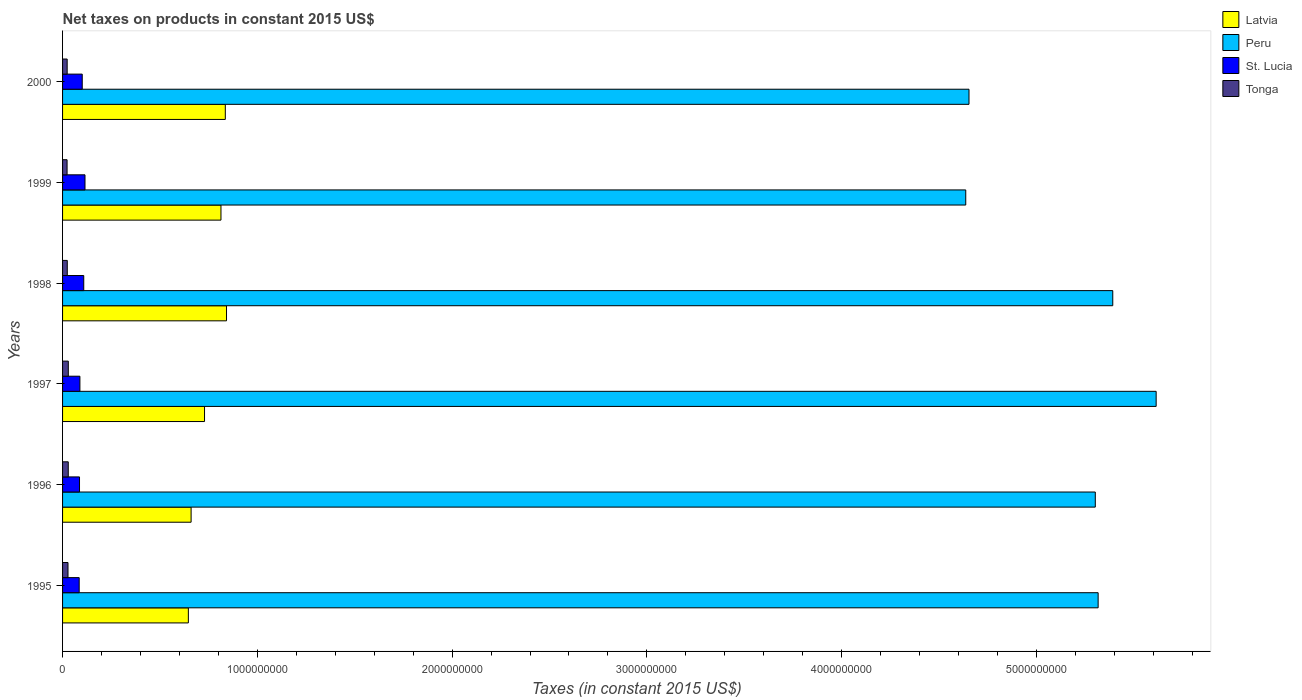Are the number of bars per tick equal to the number of legend labels?
Keep it short and to the point. Yes. Are the number of bars on each tick of the Y-axis equal?
Offer a terse response. Yes. How many bars are there on the 2nd tick from the bottom?
Offer a very short reply. 4. What is the label of the 3rd group of bars from the top?
Keep it short and to the point. 1998. What is the net taxes on products in Tonga in 1999?
Your answer should be very brief. 2.32e+07. Across all years, what is the maximum net taxes on products in Latvia?
Provide a short and direct response. 8.42e+08. Across all years, what is the minimum net taxes on products in Latvia?
Your answer should be compact. 6.46e+08. In which year was the net taxes on products in Latvia maximum?
Ensure brevity in your answer.  1998. In which year was the net taxes on products in Tonga minimum?
Offer a terse response. 1999. What is the total net taxes on products in Latvia in the graph?
Your answer should be compact. 4.53e+09. What is the difference between the net taxes on products in Tonga in 1995 and that in 1998?
Give a very brief answer. 3.73e+06. What is the difference between the net taxes on products in Tonga in 1996 and the net taxes on products in Latvia in 1999?
Keep it short and to the point. -7.84e+08. What is the average net taxes on products in Latvia per year?
Provide a short and direct response. 7.54e+08. In the year 1997, what is the difference between the net taxes on products in Latvia and net taxes on products in Tonga?
Offer a very short reply. 6.99e+08. In how many years, is the net taxes on products in St. Lucia greater than 5400000000 US$?
Your answer should be very brief. 0. What is the ratio of the net taxes on products in Peru in 1997 to that in 1998?
Provide a succinct answer. 1.04. What is the difference between the highest and the second highest net taxes on products in St. Lucia?
Your response must be concise. 6.39e+06. What is the difference between the highest and the lowest net taxes on products in St. Lucia?
Provide a short and direct response. 2.98e+07. Is the sum of the net taxes on products in Latvia in 1996 and 1999 greater than the maximum net taxes on products in St. Lucia across all years?
Provide a short and direct response. Yes. What does the 1st bar from the top in 1998 represents?
Make the answer very short. Tonga. What does the 3rd bar from the bottom in 1998 represents?
Your response must be concise. St. Lucia. What is the difference between two consecutive major ticks on the X-axis?
Give a very brief answer. 1.00e+09. Does the graph contain grids?
Keep it short and to the point. No. How many legend labels are there?
Give a very brief answer. 4. What is the title of the graph?
Ensure brevity in your answer.  Net taxes on products in constant 2015 US$. Does "Greece" appear as one of the legend labels in the graph?
Ensure brevity in your answer.  No. What is the label or title of the X-axis?
Give a very brief answer. Taxes (in constant 2015 US$). What is the Taxes (in constant 2015 US$) in Latvia in 1995?
Ensure brevity in your answer.  6.46e+08. What is the Taxes (in constant 2015 US$) in Peru in 1995?
Ensure brevity in your answer.  5.32e+09. What is the Taxes (in constant 2015 US$) of St. Lucia in 1995?
Your response must be concise. 8.54e+07. What is the Taxes (in constant 2015 US$) in Tonga in 1995?
Provide a succinct answer. 2.79e+07. What is the Taxes (in constant 2015 US$) in Latvia in 1996?
Your answer should be compact. 6.60e+08. What is the Taxes (in constant 2015 US$) in Peru in 1996?
Your answer should be compact. 5.30e+09. What is the Taxes (in constant 2015 US$) in St. Lucia in 1996?
Your answer should be compact. 8.70e+07. What is the Taxes (in constant 2015 US$) of Tonga in 1996?
Provide a short and direct response. 2.92e+07. What is the Taxes (in constant 2015 US$) of Latvia in 1997?
Keep it short and to the point. 7.29e+08. What is the Taxes (in constant 2015 US$) of Peru in 1997?
Your response must be concise. 5.61e+09. What is the Taxes (in constant 2015 US$) of St. Lucia in 1997?
Keep it short and to the point. 8.90e+07. What is the Taxes (in constant 2015 US$) of Tonga in 1997?
Your answer should be very brief. 2.95e+07. What is the Taxes (in constant 2015 US$) of Latvia in 1998?
Provide a succinct answer. 8.42e+08. What is the Taxes (in constant 2015 US$) in Peru in 1998?
Offer a very short reply. 5.39e+09. What is the Taxes (in constant 2015 US$) in St. Lucia in 1998?
Offer a terse response. 1.09e+08. What is the Taxes (in constant 2015 US$) of Tonga in 1998?
Keep it short and to the point. 2.42e+07. What is the Taxes (in constant 2015 US$) of Latvia in 1999?
Offer a terse response. 8.13e+08. What is the Taxes (in constant 2015 US$) in Peru in 1999?
Offer a very short reply. 4.64e+09. What is the Taxes (in constant 2015 US$) in St. Lucia in 1999?
Keep it short and to the point. 1.15e+08. What is the Taxes (in constant 2015 US$) of Tonga in 1999?
Keep it short and to the point. 2.32e+07. What is the Taxes (in constant 2015 US$) in Latvia in 2000?
Keep it short and to the point. 8.36e+08. What is the Taxes (in constant 2015 US$) of Peru in 2000?
Make the answer very short. 4.65e+09. What is the Taxes (in constant 2015 US$) of St. Lucia in 2000?
Your answer should be compact. 1.01e+08. What is the Taxes (in constant 2015 US$) in Tonga in 2000?
Provide a short and direct response. 2.36e+07. Across all years, what is the maximum Taxes (in constant 2015 US$) in Latvia?
Your answer should be compact. 8.42e+08. Across all years, what is the maximum Taxes (in constant 2015 US$) of Peru?
Your answer should be compact. 5.61e+09. Across all years, what is the maximum Taxes (in constant 2015 US$) of St. Lucia?
Your answer should be very brief. 1.15e+08. Across all years, what is the maximum Taxes (in constant 2015 US$) in Tonga?
Ensure brevity in your answer.  2.95e+07. Across all years, what is the minimum Taxes (in constant 2015 US$) of Latvia?
Your answer should be very brief. 6.46e+08. Across all years, what is the minimum Taxes (in constant 2015 US$) of Peru?
Keep it short and to the point. 4.64e+09. Across all years, what is the minimum Taxes (in constant 2015 US$) of St. Lucia?
Offer a very short reply. 8.54e+07. Across all years, what is the minimum Taxes (in constant 2015 US$) of Tonga?
Offer a very short reply. 2.32e+07. What is the total Taxes (in constant 2015 US$) of Latvia in the graph?
Your answer should be compact. 4.53e+09. What is the total Taxes (in constant 2015 US$) in Peru in the graph?
Your answer should be compact. 3.09e+1. What is the total Taxes (in constant 2015 US$) in St. Lucia in the graph?
Give a very brief answer. 5.86e+08. What is the total Taxes (in constant 2015 US$) of Tonga in the graph?
Make the answer very short. 1.58e+08. What is the difference between the Taxes (in constant 2015 US$) of Latvia in 1995 and that in 1996?
Offer a terse response. -1.41e+07. What is the difference between the Taxes (in constant 2015 US$) of Peru in 1995 and that in 1996?
Keep it short and to the point. 1.46e+07. What is the difference between the Taxes (in constant 2015 US$) of St. Lucia in 1995 and that in 1996?
Your answer should be compact. -1.67e+06. What is the difference between the Taxes (in constant 2015 US$) in Tonga in 1995 and that in 1996?
Make the answer very short. -1.31e+06. What is the difference between the Taxes (in constant 2015 US$) of Latvia in 1995 and that in 1997?
Your response must be concise. -8.30e+07. What is the difference between the Taxes (in constant 2015 US$) in Peru in 1995 and that in 1997?
Keep it short and to the point. -2.98e+08. What is the difference between the Taxes (in constant 2015 US$) in St. Lucia in 1995 and that in 1997?
Provide a short and direct response. -3.63e+06. What is the difference between the Taxes (in constant 2015 US$) of Tonga in 1995 and that in 1997?
Offer a terse response. -1.54e+06. What is the difference between the Taxes (in constant 2015 US$) of Latvia in 1995 and that in 1998?
Make the answer very short. -1.96e+08. What is the difference between the Taxes (in constant 2015 US$) in Peru in 1995 and that in 1998?
Keep it short and to the point. -7.51e+07. What is the difference between the Taxes (in constant 2015 US$) of St. Lucia in 1995 and that in 1998?
Keep it short and to the point. -2.34e+07. What is the difference between the Taxes (in constant 2015 US$) in Tonga in 1995 and that in 1998?
Provide a succinct answer. 3.73e+06. What is the difference between the Taxes (in constant 2015 US$) in Latvia in 1995 and that in 1999?
Keep it short and to the point. -1.67e+08. What is the difference between the Taxes (in constant 2015 US$) in Peru in 1995 and that in 1999?
Provide a succinct answer. 6.80e+08. What is the difference between the Taxes (in constant 2015 US$) of St. Lucia in 1995 and that in 1999?
Ensure brevity in your answer.  -2.98e+07. What is the difference between the Taxes (in constant 2015 US$) in Tonga in 1995 and that in 1999?
Ensure brevity in your answer.  4.76e+06. What is the difference between the Taxes (in constant 2015 US$) in Latvia in 1995 and that in 2000?
Provide a succinct answer. -1.90e+08. What is the difference between the Taxes (in constant 2015 US$) of Peru in 1995 and that in 2000?
Offer a very short reply. 6.63e+08. What is the difference between the Taxes (in constant 2015 US$) in St. Lucia in 1995 and that in 2000?
Provide a succinct answer. -1.56e+07. What is the difference between the Taxes (in constant 2015 US$) of Tonga in 1995 and that in 2000?
Give a very brief answer. 4.28e+06. What is the difference between the Taxes (in constant 2015 US$) in Latvia in 1996 and that in 1997?
Your response must be concise. -6.89e+07. What is the difference between the Taxes (in constant 2015 US$) in Peru in 1996 and that in 1997?
Ensure brevity in your answer.  -3.12e+08. What is the difference between the Taxes (in constant 2015 US$) in St. Lucia in 1996 and that in 1997?
Keep it short and to the point. -1.96e+06. What is the difference between the Taxes (in constant 2015 US$) in Tonga in 1996 and that in 1997?
Give a very brief answer. -2.30e+05. What is the difference between the Taxes (in constant 2015 US$) in Latvia in 1996 and that in 1998?
Provide a short and direct response. -1.82e+08. What is the difference between the Taxes (in constant 2015 US$) of Peru in 1996 and that in 1998?
Offer a very short reply. -8.97e+07. What is the difference between the Taxes (in constant 2015 US$) of St. Lucia in 1996 and that in 1998?
Offer a terse response. -2.17e+07. What is the difference between the Taxes (in constant 2015 US$) of Tonga in 1996 and that in 1998?
Make the answer very short. 5.04e+06. What is the difference between the Taxes (in constant 2015 US$) in Latvia in 1996 and that in 1999?
Offer a terse response. -1.53e+08. What is the difference between the Taxes (in constant 2015 US$) of Peru in 1996 and that in 1999?
Keep it short and to the point. 6.65e+08. What is the difference between the Taxes (in constant 2015 US$) in St. Lucia in 1996 and that in 1999?
Make the answer very short. -2.81e+07. What is the difference between the Taxes (in constant 2015 US$) of Tonga in 1996 and that in 1999?
Provide a short and direct response. 6.07e+06. What is the difference between the Taxes (in constant 2015 US$) in Latvia in 1996 and that in 2000?
Your response must be concise. -1.76e+08. What is the difference between the Taxes (in constant 2015 US$) of Peru in 1996 and that in 2000?
Make the answer very short. 6.48e+08. What is the difference between the Taxes (in constant 2015 US$) of St. Lucia in 1996 and that in 2000?
Keep it short and to the point. -1.40e+07. What is the difference between the Taxes (in constant 2015 US$) in Tonga in 1996 and that in 2000?
Offer a terse response. 5.59e+06. What is the difference between the Taxes (in constant 2015 US$) in Latvia in 1997 and that in 1998?
Your answer should be compact. -1.13e+08. What is the difference between the Taxes (in constant 2015 US$) in Peru in 1997 and that in 1998?
Ensure brevity in your answer.  2.23e+08. What is the difference between the Taxes (in constant 2015 US$) in St. Lucia in 1997 and that in 1998?
Your answer should be very brief. -1.98e+07. What is the difference between the Taxes (in constant 2015 US$) in Tonga in 1997 and that in 1998?
Provide a short and direct response. 5.27e+06. What is the difference between the Taxes (in constant 2015 US$) of Latvia in 1997 and that in 1999?
Offer a very short reply. -8.44e+07. What is the difference between the Taxes (in constant 2015 US$) of Peru in 1997 and that in 1999?
Give a very brief answer. 9.78e+08. What is the difference between the Taxes (in constant 2015 US$) in St. Lucia in 1997 and that in 1999?
Ensure brevity in your answer.  -2.61e+07. What is the difference between the Taxes (in constant 2015 US$) in Tonga in 1997 and that in 1999?
Provide a succinct answer. 6.30e+06. What is the difference between the Taxes (in constant 2015 US$) in Latvia in 1997 and that in 2000?
Offer a terse response. -1.07e+08. What is the difference between the Taxes (in constant 2015 US$) in Peru in 1997 and that in 2000?
Your response must be concise. 9.61e+08. What is the difference between the Taxes (in constant 2015 US$) in St. Lucia in 1997 and that in 2000?
Your response must be concise. -1.20e+07. What is the difference between the Taxes (in constant 2015 US$) of Tonga in 1997 and that in 2000?
Give a very brief answer. 5.82e+06. What is the difference between the Taxes (in constant 2015 US$) in Latvia in 1998 and that in 1999?
Your answer should be compact. 2.85e+07. What is the difference between the Taxes (in constant 2015 US$) in Peru in 1998 and that in 1999?
Give a very brief answer. 7.55e+08. What is the difference between the Taxes (in constant 2015 US$) of St. Lucia in 1998 and that in 1999?
Your answer should be very brief. -6.39e+06. What is the difference between the Taxes (in constant 2015 US$) of Tonga in 1998 and that in 1999?
Provide a succinct answer. 1.03e+06. What is the difference between the Taxes (in constant 2015 US$) in Latvia in 1998 and that in 2000?
Make the answer very short. 6.22e+06. What is the difference between the Taxes (in constant 2015 US$) in Peru in 1998 and that in 2000?
Your response must be concise. 7.38e+08. What is the difference between the Taxes (in constant 2015 US$) in St. Lucia in 1998 and that in 2000?
Your response must be concise. 7.74e+06. What is the difference between the Taxes (in constant 2015 US$) of Tonga in 1998 and that in 2000?
Your answer should be compact. 5.47e+05. What is the difference between the Taxes (in constant 2015 US$) of Latvia in 1999 and that in 2000?
Provide a succinct answer. -2.22e+07. What is the difference between the Taxes (in constant 2015 US$) in Peru in 1999 and that in 2000?
Offer a very short reply. -1.66e+07. What is the difference between the Taxes (in constant 2015 US$) in St. Lucia in 1999 and that in 2000?
Keep it short and to the point. 1.41e+07. What is the difference between the Taxes (in constant 2015 US$) of Tonga in 1999 and that in 2000?
Offer a very short reply. -4.79e+05. What is the difference between the Taxes (in constant 2015 US$) of Latvia in 1995 and the Taxes (in constant 2015 US$) of Peru in 1996?
Give a very brief answer. -4.66e+09. What is the difference between the Taxes (in constant 2015 US$) of Latvia in 1995 and the Taxes (in constant 2015 US$) of St. Lucia in 1996?
Keep it short and to the point. 5.59e+08. What is the difference between the Taxes (in constant 2015 US$) of Latvia in 1995 and the Taxes (in constant 2015 US$) of Tonga in 1996?
Provide a succinct answer. 6.17e+08. What is the difference between the Taxes (in constant 2015 US$) in Peru in 1995 and the Taxes (in constant 2015 US$) in St. Lucia in 1996?
Offer a very short reply. 5.23e+09. What is the difference between the Taxes (in constant 2015 US$) of Peru in 1995 and the Taxes (in constant 2015 US$) of Tonga in 1996?
Provide a short and direct response. 5.29e+09. What is the difference between the Taxes (in constant 2015 US$) in St. Lucia in 1995 and the Taxes (in constant 2015 US$) in Tonga in 1996?
Your response must be concise. 5.61e+07. What is the difference between the Taxes (in constant 2015 US$) of Latvia in 1995 and the Taxes (in constant 2015 US$) of Peru in 1997?
Your response must be concise. -4.97e+09. What is the difference between the Taxes (in constant 2015 US$) in Latvia in 1995 and the Taxes (in constant 2015 US$) in St. Lucia in 1997?
Offer a very short reply. 5.57e+08. What is the difference between the Taxes (in constant 2015 US$) of Latvia in 1995 and the Taxes (in constant 2015 US$) of Tonga in 1997?
Make the answer very short. 6.16e+08. What is the difference between the Taxes (in constant 2015 US$) of Peru in 1995 and the Taxes (in constant 2015 US$) of St. Lucia in 1997?
Provide a short and direct response. 5.23e+09. What is the difference between the Taxes (in constant 2015 US$) in Peru in 1995 and the Taxes (in constant 2015 US$) in Tonga in 1997?
Make the answer very short. 5.29e+09. What is the difference between the Taxes (in constant 2015 US$) in St. Lucia in 1995 and the Taxes (in constant 2015 US$) in Tonga in 1997?
Your answer should be very brief. 5.59e+07. What is the difference between the Taxes (in constant 2015 US$) in Latvia in 1995 and the Taxes (in constant 2015 US$) in Peru in 1998?
Make the answer very short. -4.75e+09. What is the difference between the Taxes (in constant 2015 US$) of Latvia in 1995 and the Taxes (in constant 2015 US$) of St. Lucia in 1998?
Your answer should be compact. 5.37e+08. What is the difference between the Taxes (in constant 2015 US$) in Latvia in 1995 and the Taxes (in constant 2015 US$) in Tonga in 1998?
Offer a very short reply. 6.22e+08. What is the difference between the Taxes (in constant 2015 US$) of Peru in 1995 and the Taxes (in constant 2015 US$) of St. Lucia in 1998?
Your answer should be compact. 5.21e+09. What is the difference between the Taxes (in constant 2015 US$) in Peru in 1995 and the Taxes (in constant 2015 US$) in Tonga in 1998?
Your response must be concise. 5.29e+09. What is the difference between the Taxes (in constant 2015 US$) in St. Lucia in 1995 and the Taxes (in constant 2015 US$) in Tonga in 1998?
Your answer should be compact. 6.12e+07. What is the difference between the Taxes (in constant 2015 US$) in Latvia in 1995 and the Taxes (in constant 2015 US$) in Peru in 1999?
Make the answer very short. -3.99e+09. What is the difference between the Taxes (in constant 2015 US$) in Latvia in 1995 and the Taxes (in constant 2015 US$) in St. Lucia in 1999?
Keep it short and to the point. 5.31e+08. What is the difference between the Taxes (in constant 2015 US$) of Latvia in 1995 and the Taxes (in constant 2015 US$) of Tonga in 1999?
Provide a short and direct response. 6.23e+08. What is the difference between the Taxes (in constant 2015 US$) of Peru in 1995 and the Taxes (in constant 2015 US$) of St. Lucia in 1999?
Ensure brevity in your answer.  5.20e+09. What is the difference between the Taxes (in constant 2015 US$) of Peru in 1995 and the Taxes (in constant 2015 US$) of Tonga in 1999?
Make the answer very short. 5.29e+09. What is the difference between the Taxes (in constant 2015 US$) in St. Lucia in 1995 and the Taxes (in constant 2015 US$) in Tonga in 1999?
Your answer should be compact. 6.22e+07. What is the difference between the Taxes (in constant 2015 US$) in Latvia in 1995 and the Taxes (in constant 2015 US$) in Peru in 2000?
Provide a succinct answer. -4.01e+09. What is the difference between the Taxes (in constant 2015 US$) of Latvia in 1995 and the Taxes (in constant 2015 US$) of St. Lucia in 2000?
Provide a succinct answer. 5.45e+08. What is the difference between the Taxes (in constant 2015 US$) of Latvia in 1995 and the Taxes (in constant 2015 US$) of Tonga in 2000?
Give a very brief answer. 6.22e+08. What is the difference between the Taxes (in constant 2015 US$) of Peru in 1995 and the Taxes (in constant 2015 US$) of St. Lucia in 2000?
Your response must be concise. 5.22e+09. What is the difference between the Taxes (in constant 2015 US$) of Peru in 1995 and the Taxes (in constant 2015 US$) of Tonga in 2000?
Your answer should be compact. 5.29e+09. What is the difference between the Taxes (in constant 2015 US$) in St. Lucia in 1995 and the Taxes (in constant 2015 US$) in Tonga in 2000?
Make the answer very short. 6.17e+07. What is the difference between the Taxes (in constant 2015 US$) of Latvia in 1996 and the Taxes (in constant 2015 US$) of Peru in 1997?
Provide a short and direct response. -4.95e+09. What is the difference between the Taxes (in constant 2015 US$) in Latvia in 1996 and the Taxes (in constant 2015 US$) in St. Lucia in 1997?
Provide a short and direct response. 5.71e+08. What is the difference between the Taxes (in constant 2015 US$) of Latvia in 1996 and the Taxes (in constant 2015 US$) of Tonga in 1997?
Offer a very short reply. 6.31e+08. What is the difference between the Taxes (in constant 2015 US$) in Peru in 1996 and the Taxes (in constant 2015 US$) in St. Lucia in 1997?
Offer a terse response. 5.21e+09. What is the difference between the Taxes (in constant 2015 US$) of Peru in 1996 and the Taxes (in constant 2015 US$) of Tonga in 1997?
Provide a short and direct response. 5.27e+09. What is the difference between the Taxes (in constant 2015 US$) in St. Lucia in 1996 and the Taxes (in constant 2015 US$) in Tonga in 1997?
Your answer should be very brief. 5.76e+07. What is the difference between the Taxes (in constant 2015 US$) of Latvia in 1996 and the Taxes (in constant 2015 US$) of Peru in 1998?
Provide a succinct answer. -4.73e+09. What is the difference between the Taxes (in constant 2015 US$) of Latvia in 1996 and the Taxes (in constant 2015 US$) of St. Lucia in 1998?
Provide a short and direct response. 5.51e+08. What is the difference between the Taxes (in constant 2015 US$) of Latvia in 1996 and the Taxes (in constant 2015 US$) of Tonga in 1998?
Provide a succinct answer. 6.36e+08. What is the difference between the Taxes (in constant 2015 US$) of Peru in 1996 and the Taxes (in constant 2015 US$) of St. Lucia in 1998?
Your response must be concise. 5.19e+09. What is the difference between the Taxes (in constant 2015 US$) of Peru in 1996 and the Taxes (in constant 2015 US$) of Tonga in 1998?
Your response must be concise. 5.28e+09. What is the difference between the Taxes (in constant 2015 US$) of St. Lucia in 1996 and the Taxes (in constant 2015 US$) of Tonga in 1998?
Make the answer very short. 6.28e+07. What is the difference between the Taxes (in constant 2015 US$) in Latvia in 1996 and the Taxes (in constant 2015 US$) in Peru in 1999?
Make the answer very short. -3.98e+09. What is the difference between the Taxes (in constant 2015 US$) in Latvia in 1996 and the Taxes (in constant 2015 US$) in St. Lucia in 1999?
Make the answer very short. 5.45e+08. What is the difference between the Taxes (in constant 2015 US$) of Latvia in 1996 and the Taxes (in constant 2015 US$) of Tonga in 1999?
Ensure brevity in your answer.  6.37e+08. What is the difference between the Taxes (in constant 2015 US$) in Peru in 1996 and the Taxes (in constant 2015 US$) in St. Lucia in 1999?
Your answer should be very brief. 5.19e+09. What is the difference between the Taxes (in constant 2015 US$) of Peru in 1996 and the Taxes (in constant 2015 US$) of Tonga in 1999?
Provide a succinct answer. 5.28e+09. What is the difference between the Taxes (in constant 2015 US$) of St. Lucia in 1996 and the Taxes (in constant 2015 US$) of Tonga in 1999?
Your response must be concise. 6.39e+07. What is the difference between the Taxes (in constant 2015 US$) in Latvia in 1996 and the Taxes (in constant 2015 US$) in Peru in 2000?
Offer a very short reply. -3.99e+09. What is the difference between the Taxes (in constant 2015 US$) of Latvia in 1996 and the Taxes (in constant 2015 US$) of St. Lucia in 2000?
Make the answer very short. 5.59e+08. What is the difference between the Taxes (in constant 2015 US$) of Latvia in 1996 and the Taxes (in constant 2015 US$) of Tonga in 2000?
Make the answer very short. 6.36e+08. What is the difference between the Taxes (in constant 2015 US$) in Peru in 1996 and the Taxes (in constant 2015 US$) in St. Lucia in 2000?
Your answer should be compact. 5.20e+09. What is the difference between the Taxes (in constant 2015 US$) of Peru in 1996 and the Taxes (in constant 2015 US$) of Tonga in 2000?
Your answer should be compact. 5.28e+09. What is the difference between the Taxes (in constant 2015 US$) in St. Lucia in 1996 and the Taxes (in constant 2015 US$) in Tonga in 2000?
Ensure brevity in your answer.  6.34e+07. What is the difference between the Taxes (in constant 2015 US$) in Latvia in 1997 and the Taxes (in constant 2015 US$) in Peru in 1998?
Provide a short and direct response. -4.66e+09. What is the difference between the Taxes (in constant 2015 US$) in Latvia in 1997 and the Taxes (in constant 2015 US$) in St. Lucia in 1998?
Offer a terse response. 6.20e+08. What is the difference between the Taxes (in constant 2015 US$) in Latvia in 1997 and the Taxes (in constant 2015 US$) in Tonga in 1998?
Offer a terse response. 7.05e+08. What is the difference between the Taxes (in constant 2015 US$) in Peru in 1997 and the Taxes (in constant 2015 US$) in St. Lucia in 1998?
Keep it short and to the point. 5.51e+09. What is the difference between the Taxes (in constant 2015 US$) of Peru in 1997 and the Taxes (in constant 2015 US$) of Tonga in 1998?
Ensure brevity in your answer.  5.59e+09. What is the difference between the Taxes (in constant 2015 US$) of St. Lucia in 1997 and the Taxes (in constant 2015 US$) of Tonga in 1998?
Provide a short and direct response. 6.48e+07. What is the difference between the Taxes (in constant 2015 US$) in Latvia in 1997 and the Taxes (in constant 2015 US$) in Peru in 1999?
Make the answer very short. -3.91e+09. What is the difference between the Taxes (in constant 2015 US$) of Latvia in 1997 and the Taxes (in constant 2015 US$) of St. Lucia in 1999?
Keep it short and to the point. 6.14e+08. What is the difference between the Taxes (in constant 2015 US$) of Latvia in 1997 and the Taxes (in constant 2015 US$) of Tonga in 1999?
Keep it short and to the point. 7.06e+08. What is the difference between the Taxes (in constant 2015 US$) of Peru in 1997 and the Taxes (in constant 2015 US$) of St. Lucia in 1999?
Make the answer very short. 5.50e+09. What is the difference between the Taxes (in constant 2015 US$) of Peru in 1997 and the Taxes (in constant 2015 US$) of Tonga in 1999?
Give a very brief answer. 5.59e+09. What is the difference between the Taxes (in constant 2015 US$) in St. Lucia in 1997 and the Taxes (in constant 2015 US$) in Tonga in 1999?
Keep it short and to the point. 6.58e+07. What is the difference between the Taxes (in constant 2015 US$) in Latvia in 1997 and the Taxes (in constant 2015 US$) in Peru in 2000?
Your answer should be very brief. -3.92e+09. What is the difference between the Taxes (in constant 2015 US$) in Latvia in 1997 and the Taxes (in constant 2015 US$) in St. Lucia in 2000?
Your answer should be compact. 6.28e+08. What is the difference between the Taxes (in constant 2015 US$) in Latvia in 1997 and the Taxes (in constant 2015 US$) in Tonga in 2000?
Keep it short and to the point. 7.05e+08. What is the difference between the Taxes (in constant 2015 US$) of Peru in 1997 and the Taxes (in constant 2015 US$) of St. Lucia in 2000?
Offer a very short reply. 5.51e+09. What is the difference between the Taxes (in constant 2015 US$) of Peru in 1997 and the Taxes (in constant 2015 US$) of Tonga in 2000?
Provide a succinct answer. 5.59e+09. What is the difference between the Taxes (in constant 2015 US$) in St. Lucia in 1997 and the Taxes (in constant 2015 US$) in Tonga in 2000?
Offer a very short reply. 6.54e+07. What is the difference between the Taxes (in constant 2015 US$) in Latvia in 1998 and the Taxes (in constant 2015 US$) in Peru in 1999?
Provide a succinct answer. -3.80e+09. What is the difference between the Taxes (in constant 2015 US$) of Latvia in 1998 and the Taxes (in constant 2015 US$) of St. Lucia in 1999?
Provide a succinct answer. 7.27e+08. What is the difference between the Taxes (in constant 2015 US$) in Latvia in 1998 and the Taxes (in constant 2015 US$) in Tonga in 1999?
Keep it short and to the point. 8.19e+08. What is the difference between the Taxes (in constant 2015 US$) in Peru in 1998 and the Taxes (in constant 2015 US$) in St. Lucia in 1999?
Make the answer very short. 5.28e+09. What is the difference between the Taxes (in constant 2015 US$) in Peru in 1998 and the Taxes (in constant 2015 US$) in Tonga in 1999?
Make the answer very short. 5.37e+09. What is the difference between the Taxes (in constant 2015 US$) in St. Lucia in 1998 and the Taxes (in constant 2015 US$) in Tonga in 1999?
Offer a very short reply. 8.56e+07. What is the difference between the Taxes (in constant 2015 US$) in Latvia in 1998 and the Taxes (in constant 2015 US$) in Peru in 2000?
Your answer should be very brief. -3.81e+09. What is the difference between the Taxes (in constant 2015 US$) of Latvia in 1998 and the Taxes (in constant 2015 US$) of St. Lucia in 2000?
Ensure brevity in your answer.  7.41e+08. What is the difference between the Taxes (in constant 2015 US$) in Latvia in 1998 and the Taxes (in constant 2015 US$) in Tonga in 2000?
Make the answer very short. 8.18e+08. What is the difference between the Taxes (in constant 2015 US$) of Peru in 1998 and the Taxes (in constant 2015 US$) of St. Lucia in 2000?
Provide a short and direct response. 5.29e+09. What is the difference between the Taxes (in constant 2015 US$) of Peru in 1998 and the Taxes (in constant 2015 US$) of Tonga in 2000?
Keep it short and to the point. 5.37e+09. What is the difference between the Taxes (in constant 2015 US$) in St. Lucia in 1998 and the Taxes (in constant 2015 US$) in Tonga in 2000?
Make the answer very short. 8.51e+07. What is the difference between the Taxes (in constant 2015 US$) in Latvia in 1999 and the Taxes (in constant 2015 US$) in Peru in 2000?
Offer a very short reply. -3.84e+09. What is the difference between the Taxes (in constant 2015 US$) of Latvia in 1999 and the Taxes (in constant 2015 US$) of St. Lucia in 2000?
Your response must be concise. 7.12e+08. What is the difference between the Taxes (in constant 2015 US$) of Latvia in 1999 and the Taxes (in constant 2015 US$) of Tonga in 2000?
Ensure brevity in your answer.  7.90e+08. What is the difference between the Taxes (in constant 2015 US$) of Peru in 1999 and the Taxes (in constant 2015 US$) of St. Lucia in 2000?
Offer a very short reply. 4.54e+09. What is the difference between the Taxes (in constant 2015 US$) in Peru in 1999 and the Taxes (in constant 2015 US$) in Tonga in 2000?
Your answer should be very brief. 4.61e+09. What is the difference between the Taxes (in constant 2015 US$) of St. Lucia in 1999 and the Taxes (in constant 2015 US$) of Tonga in 2000?
Your answer should be very brief. 9.15e+07. What is the average Taxes (in constant 2015 US$) of Latvia per year?
Keep it short and to the point. 7.54e+08. What is the average Taxes (in constant 2015 US$) of Peru per year?
Your answer should be very brief. 5.15e+09. What is the average Taxes (in constant 2015 US$) of St. Lucia per year?
Your answer should be very brief. 9.77e+07. What is the average Taxes (in constant 2015 US$) in Tonga per year?
Offer a terse response. 2.63e+07. In the year 1995, what is the difference between the Taxes (in constant 2015 US$) of Latvia and Taxes (in constant 2015 US$) of Peru?
Provide a short and direct response. -4.67e+09. In the year 1995, what is the difference between the Taxes (in constant 2015 US$) in Latvia and Taxes (in constant 2015 US$) in St. Lucia?
Offer a terse response. 5.60e+08. In the year 1995, what is the difference between the Taxes (in constant 2015 US$) of Latvia and Taxes (in constant 2015 US$) of Tonga?
Your answer should be very brief. 6.18e+08. In the year 1995, what is the difference between the Taxes (in constant 2015 US$) of Peru and Taxes (in constant 2015 US$) of St. Lucia?
Your answer should be compact. 5.23e+09. In the year 1995, what is the difference between the Taxes (in constant 2015 US$) in Peru and Taxes (in constant 2015 US$) in Tonga?
Provide a short and direct response. 5.29e+09. In the year 1995, what is the difference between the Taxes (in constant 2015 US$) in St. Lucia and Taxes (in constant 2015 US$) in Tonga?
Give a very brief answer. 5.74e+07. In the year 1996, what is the difference between the Taxes (in constant 2015 US$) of Latvia and Taxes (in constant 2015 US$) of Peru?
Keep it short and to the point. -4.64e+09. In the year 1996, what is the difference between the Taxes (in constant 2015 US$) in Latvia and Taxes (in constant 2015 US$) in St. Lucia?
Your answer should be very brief. 5.73e+08. In the year 1996, what is the difference between the Taxes (in constant 2015 US$) in Latvia and Taxes (in constant 2015 US$) in Tonga?
Offer a terse response. 6.31e+08. In the year 1996, what is the difference between the Taxes (in constant 2015 US$) in Peru and Taxes (in constant 2015 US$) in St. Lucia?
Your response must be concise. 5.22e+09. In the year 1996, what is the difference between the Taxes (in constant 2015 US$) in Peru and Taxes (in constant 2015 US$) in Tonga?
Your answer should be very brief. 5.27e+09. In the year 1996, what is the difference between the Taxes (in constant 2015 US$) of St. Lucia and Taxes (in constant 2015 US$) of Tonga?
Keep it short and to the point. 5.78e+07. In the year 1997, what is the difference between the Taxes (in constant 2015 US$) in Latvia and Taxes (in constant 2015 US$) in Peru?
Offer a very short reply. -4.89e+09. In the year 1997, what is the difference between the Taxes (in constant 2015 US$) in Latvia and Taxes (in constant 2015 US$) in St. Lucia?
Offer a very short reply. 6.40e+08. In the year 1997, what is the difference between the Taxes (in constant 2015 US$) in Latvia and Taxes (in constant 2015 US$) in Tonga?
Make the answer very short. 6.99e+08. In the year 1997, what is the difference between the Taxes (in constant 2015 US$) of Peru and Taxes (in constant 2015 US$) of St. Lucia?
Provide a short and direct response. 5.53e+09. In the year 1997, what is the difference between the Taxes (in constant 2015 US$) in Peru and Taxes (in constant 2015 US$) in Tonga?
Your answer should be very brief. 5.59e+09. In the year 1997, what is the difference between the Taxes (in constant 2015 US$) in St. Lucia and Taxes (in constant 2015 US$) in Tonga?
Offer a very short reply. 5.95e+07. In the year 1998, what is the difference between the Taxes (in constant 2015 US$) of Latvia and Taxes (in constant 2015 US$) of Peru?
Provide a short and direct response. -4.55e+09. In the year 1998, what is the difference between the Taxes (in constant 2015 US$) in Latvia and Taxes (in constant 2015 US$) in St. Lucia?
Provide a succinct answer. 7.33e+08. In the year 1998, what is the difference between the Taxes (in constant 2015 US$) in Latvia and Taxes (in constant 2015 US$) in Tonga?
Give a very brief answer. 8.18e+08. In the year 1998, what is the difference between the Taxes (in constant 2015 US$) of Peru and Taxes (in constant 2015 US$) of St. Lucia?
Give a very brief answer. 5.28e+09. In the year 1998, what is the difference between the Taxes (in constant 2015 US$) in Peru and Taxes (in constant 2015 US$) in Tonga?
Offer a very short reply. 5.37e+09. In the year 1998, what is the difference between the Taxes (in constant 2015 US$) in St. Lucia and Taxes (in constant 2015 US$) in Tonga?
Offer a terse response. 8.46e+07. In the year 1999, what is the difference between the Taxes (in constant 2015 US$) in Latvia and Taxes (in constant 2015 US$) in Peru?
Your answer should be compact. -3.82e+09. In the year 1999, what is the difference between the Taxes (in constant 2015 US$) of Latvia and Taxes (in constant 2015 US$) of St. Lucia?
Make the answer very short. 6.98e+08. In the year 1999, what is the difference between the Taxes (in constant 2015 US$) in Latvia and Taxes (in constant 2015 US$) in Tonga?
Your answer should be compact. 7.90e+08. In the year 1999, what is the difference between the Taxes (in constant 2015 US$) in Peru and Taxes (in constant 2015 US$) in St. Lucia?
Keep it short and to the point. 4.52e+09. In the year 1999, what is the difference between the Taxes (in constant 2015 US$) of Peru and Taxes (in constant 2015 US$) of Tonga?
Offer a terse response. 4.61e+09. In the year 1999, what is the difference between the Taxes (in constant 2015 US$) in St. Lucia and Taxes (in constant 2015 US$) in Tonga?
Your answer should be very brief. 9.20e+07. In the year 2000, what is the difference between the Taxes (in constant 2015 US$) in Latvia and Taxes (in constant 2015 US$) in Peru?
Offer a very short reply. -3.82e+09. In the year 2000, what is the difference between the Taxes (in constant 2015 US$) of Latvia and Taxes (in constant 2015 US$) of St. Lucia?
Make the answer very short. 7.35e+08. In the year 2000, what is the difference between the Taxes (in constant 2015 US$) in Latvia and Taxes (in constant 2015 US$) in Tonga?
Give a very brief answer. 8.12e+08. In the year 2000, what is the difference between the Taxes (in constant 2015 US$) in Peru and Taxes (in constant 2015 US$) in St. Lucia?
Your answer should be very brief. 4.55e+09. In the year 2000, what is the difference between the Taxes (in constant 2015 US$) of Peru and Taxes (in constant 2015 US$) of Tonga?
Provide a short and direct response. 4.63e+09. In the year 2000, what is the difference between the Taxes (in constant 2015 US$) of St. Lucia and Taxes (in constant 2015 US$) of Tonga?
Offer a terse response. 7.74e+07. What is the ratio of the Taxes (in constant 2015 US$) in Latvia in 1995 to that in 1996?
Ensure brevity in your answer.  0.98. What is the ratio of the Taxes (in constant 2015 US$) in St. Lucia in 1995 to that in 1996?
Your answer should be very brief. 0.98. What is the ratio of the Taxes (in constant 2015 US$) of Tonga in 1995 to that in 1996?
Make the answer very short. 0.96. What is the ratio of the Taxes (in constant 2015 US$) in Latvia in 1995 to that in 1997?
Provide a short and direct response. 0.89. What is the ratio of the Taxes (in constant 2015 US$) in Peru in 1995 to that in 1997?
Provide a succinct answer. 0.95. What is the ratio of the Taxes (in constant 2015 US$) in St. Lucia in 1995 to that in 1997?
Provide a succinct answer. 0.96. What is the ratio of the Taxes (in constant 2015 US$) of Tonga in 1995 to that in 1997?
Your answer should be compact. 0.95. What is the ratio of the Taxes (in constant 2015 US$) of Latvia in 1995 to that in 1998?
Offer a very short reply. 0.77. What is the ratio of the Taxes (in constant 2015 US$) of Peru in 1995 to that in 1998?
Keep it short and to the point. 0.99. What is the ratio of the Taxes (in constant 2015 US$) in St. Lucia in 1995 to that in 1998?
Provide a short and direct response. 0.79. What is the ratio of the Taxes (in constant 2015 US$) of Tonga in 1995 to that in 1998?
Your answer should be very brief. 1.15. What is the ratio of the Taxes (in constant 2015 US$) of Latvia in 1995 to that in 1999?
Your response must be concise. 0.79. What is the ratio of the Taxes (in constant 2015 US$) of Peru in 1995 to that in 1999?
Provide a succinct answer. 1.15. What is the ratio of the Taxes (in constant 2015 US$) in St. Lucia in 1995 to that in 1999?
Offer a very short reply. 0.74. What is the ratio of the Taxes (in constant 2015 US$) of Tonga in 1995 to that in 1999?
Your response must be concise. 1.21. What is the ratio of the Taxes (in constant 2015 US$) of Latvia in 1995 to that in 2000?
Your response must be concise. 0.77. What is the ratio of the Taxes (in constant 2015 US$) in Peru in 1995 to that in 2000?
Give a very brief answer. 1.14. What is the ratio of the Taxes (in constant 2015 US$) of St. Lucia in 1995 to that in 2000?
Offer a very short reply. 0.85. What is the ratio of the Taxes (in constant 2015 US$) in Tonga in 1995 to that in 2000?
Offer a terse response. 1.18. What is the ratio of the Taxes (in constant 2015 US$) of Latvia in 1996 to that in 1997?
Provide a short and direct response. 0.91. What is the ratio of the Taxes (in constant 2015 US$) in Peru in 1996 to that in 1997?
Keep it short and to the point. 0.94. What is the ratio of the Taxes (in constant 2015 US$) of St. Lucia in 1996 to that in 1997?
Your response must be concise. 0.98. What is the ratio of the Taxes (in constant 2015 US$) in Tonga in 1996 to that in 1997?
Keep it short and to the point. 0.99. What is the ratio of the Taxes (in constant 2015 US$) of Latvia in 1996 to that in 1998?
Provide a succinct answer. 0.78. What is the ratio of the Taxes (in constant 2015 US$) in Peru in 1996 to that in 1998?
Provide a succinct answer. 0.98. What is the ratio of the Taxes (in constant 2015 US$) in St. Lucia in 1996 to that in 1998?
Your answer should be very brief. 0.8. What is the ratio of the Taxes (in constant 2015 US$) in Tonga in 1996 to that in 1998?
Keep it short and to the point. 1.21. What is the ratio of the Taxes (in constant 2015 US$) in Latvia in 1996 to that in 1999?
Your response must be concise. 0.81. What is the ratio of the Taxes (in constant 2015 US$) in Peru in 1996 to that in 1999?
Ensure brevity in your answer.  1.14. What is the ratio of the Taxes (in constant 2015 US$) of St. Lucia in 1996 to that in 1999?
Your answer should be compact. 0.76. What is the ratio of the Taxes (in constant 2015 US$) in Tonga in 1996 to that in 1999?
Provide a succinct answer. 1.26. What is the ratio of the Taxes (in constant 2015 US$) of Latvia in 1996 to that in 2000?
Provide a short and direct response. 0.79. What is the ratio of the Taxes (in constant 2015 US$) in Peru in 1996 to that in 2000?
Make the answer very short. 1.14. What is the ratio of the Taxes (in constant 2015 US$) in St. Lucia in 1996 to that in 2000?
Offer a terse response. 0.86. What is the ratio of the Taxes (in constant 2015 US$) of Tonga in 1996 to that in 2000?
Your answer should be very brief. 1.24. What is the ratio of the Taxes (in constant 2015 US$) of Latvia in 1997 to that in 1998?
Provide a short and direct response. 0.87. What is the ratio of the Taxes (in constant 2015 US$) in Peru in 1997 to that in 1998?
Ensure brevity in your answer.  1.04. What is the ratio of the Taxes (in constant 2015 US$) of St. Lucia in 1997 to that in 1998?
Your answer should be very brief. 0.82. What is the ratio of the Taxes (in constant 2015 US$) in Tonga in 1997 to that in 1998?
Ensure brevity in your answer.  1.22. What is the ratio of the Taxes (in constant 2015 US$) of Latvia in 1997 to that in 1999?
Keep it short and to the point. 0.9. What is the ratio of the Taxes (in constant 2015 US$) of Peru in 1997 to that in 1999?
Give a very brief answer. 1.21. What is the ratio of the Taxes (in constant 2015 US$) of St. Lucia in 1997 to that in 1999?
Give a very brief answer. 0.77. What is the ratio of the Taxes (in constant 2015 US$) in Tonga in 1997 to that in 1999?
Your answer should be very brief. 1.27. What is the ratio of the Taxes (in constant 2015 US$) in Latvia in 1997 to that in 2000?
Provide a succinct answer. 0.87. What is the ratio of the Taxes (in constant 2015 US$) in Peru in 1997 to that in 2000?
Your response must be concise. 1.21. What is the ratio of the Taxes (in constant 2015 US$) in St. Lucia in 1997 to that in 2000?
Offer a very short reply. 0.88. What is the ratio of the Taxes (in constant 2015 US$) in Tonga in 1997 to that in 2000?
Your answer should be very brief. 1.25. What is the ratio of the Taxes (in constant 2015 US$) in Latvia in 1998 to that in 1999?
Give a very brief answer. 1.03. What is the ratio of the Taxes (in constant 2015 US$) in Peru in 1998 to that in 1999?
Your response must be concise. 1.16. What is the ratio of the Taxes (in constant 2015 US$) of St. Lucia in 1998 to that in 1999?
Your answer should be very brief. 0.94. What is the ratio of the Taxes (in constant 2015 US$) in Tonga in 1998 to that in 1999?
Provide a succinct answer. 1.04. What is the ratio of the Taxes (in constant 2015 US$) of Latvia in 1998 to that in 2000?
Provide a succinct answer. 1.01. What is the ratio of the Taxes (in constant 2015 US$) of Peru in 1998 to that in 2000?
Provide a short and direct response. 1.16. What is the ratio of the Taxes (in constant 2015 US$) in St. Lucia in 1998 to that in 2000?
Your answer should be very brief. 1.08. What is the ratio of the Taxes (in constant 2015 US$) in Tonga in 1998 to that in 2000?
Offer a terse response. 1.02. What is the ratio of the Taxes (in constant 2015 US$) in Latvia in 1999 to that in 2000?
Provide a short and direct response. 0.97. What is the ratio of the Taxes (in constant 2015 US$) in Peru in 1999 to that in 2000?
Ensure brevity in your answer.  1. What is the ratio of the Taxes (in constant 2015 US$) in St. Lucia in 1999 to that in 2000?
Keep it short and to the point. 1.14. What is the ratio of the Taxes (in constant 2015 US$) in Tonga in 1999 to that in 2000?
Provide a succinct answer. 0.98. What is the difference between the highest and the second highest Taxes (in constant 2015 US$) of Latvia?
Your answer should be compact. 6.22e+06. What is the difference between the highest and the second highest Taxes (in constant 2015 US$) in Peru?
Ensure brevity in your answer.  2.23e+08. What is the difference between the highest and the second highest Taxes (in constant 2015 US$) in St. Lucia?
Provide a succinct answer. 6.39e+06. What is the difference between the highest and the second highest Taxes (in constant 2015 US$) of Tonga?
Provide a short and direct response. 2.30e+05. What is the difference between the highest and the lowest Taxes (in constant 2015 US$) of Latvia?
Make the answer very short. 1.96e+08. What is the difference between the highest and the lowest Taxes (in constant 2015 US$) of Peru?
Provide a succinct answer. 9.78e+08. What is the difference between the highest and the lowest Taxes (in constant 2015 US$) in St. Lucia?
Make the answer very short. 2.98e+07. What is the difference between the highest and the lowest Taxes (in constant 2015 US$) of Tonga?
Offer a very short reply. 6.30e+06. 